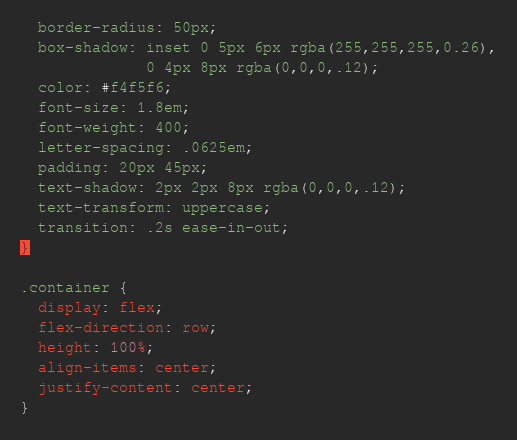Convert code to text. <code><loc_0><loc_0><loc_500><loc_500><_CSS_>  border-radius: 50px;
  box-shadow: inset 0 5px 6px rgba(255,255,255,0.26),
              0 4px 8px rgba(0,0,0,.12);
  color: #f4f5f6;
  font-size: 1.8em;
  font-weight: 400;
  letter-spacing: .0625em;
  padding: 20px 45px;
  text-shadow: 2px 2px 8px rgba(0,0,0,.12);
  text-transform: uppercase;
  transition: .2s ease-in-out;
}

.container {
  display: flex;
  flex-direction: row;
  height: 100%;
  align-items: center;
  justify-content: center;
}
</code> 